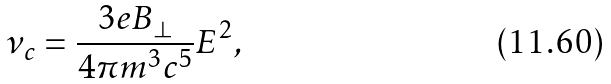Convert formula to latex. <formula><loc_0><loc_0><loc_500><loc_500>\nu _ { c } = \frac { 3 e B _ { \bot } } { 4 \pi m ^ { 3 } c ^ { 5 } } E ^ { 2 } ,</formula> 